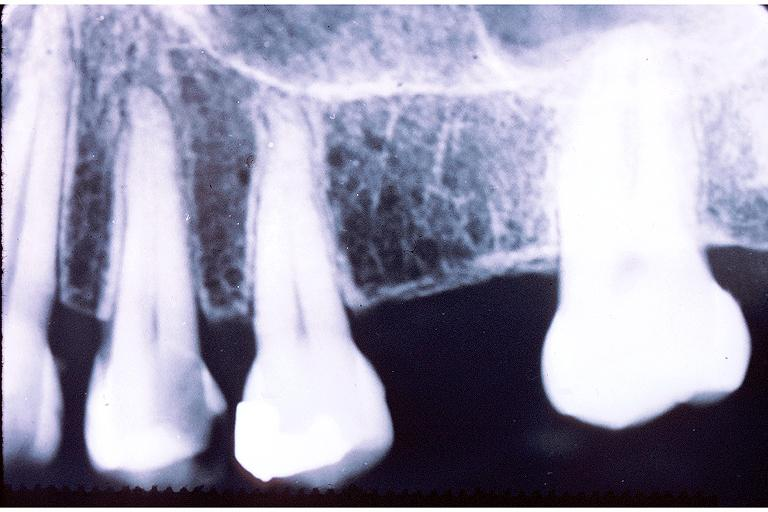where is this?
Answer the question using a single word or phrase. Oral 